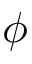Convert formula to latex. <formula><loc_0><loc_0><loc_500><loc_500>\phi</formula> 